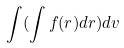Convert formula to latex. <formula><loc_0><loc_0><loc_500><loc_500>\int ( \int f ( r ) d r ) d v</formula> 